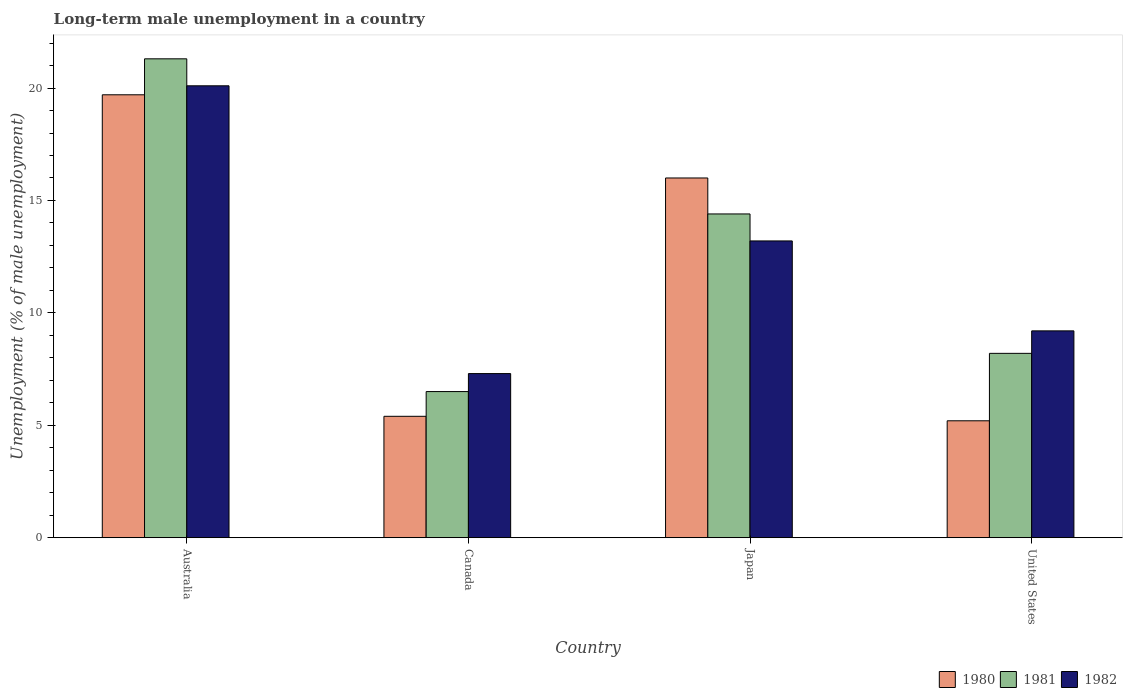How many groups of bars are there?
Keep it short and to the point. 4. What is the label of the 3rd group of bars from the left?
Offer a terse response. Japan. What is the percentage of long-term unemployed male population in 1981 in United States?
Ensure brevity in your answer.  8.2. Across all countries, what is the maximum percentage of long-term unemployed male population in 1980?
Provide a short and direct response. 19.7. In which country was the percentage of long-term unemployed male population in 1980 maximum?
Provide a succinct answer. Australia. In which country was the percentage of long-term unemployed male population in 1982 minimum?
Your response must be concise. Canada. What is the total percentage of long-term unemployed male population in 1982 in the graph?
Provide a short and direct response. 49.8. What is the difference between the percentage of long-term unemployed male population in 1982 in Canada and that in United States?
Your answer should be compact. -1.9. What is the difference between the percentage of long-term unemployed male population in 1982 in Australia and the percentage of long-term unemployed male population in 1981 in Japan?
Give a very brief answer. 5.7. What is the average percentage of long-term unemployed male population in 1981 per country?
Your response must be concise. 12.6. What is the difference between the percentage of long-term unemployed male population of/in 1982 and percentage of long-term unemployed male population of/in 1981 in Japan?
Provide a short and direct response. -1.2. What is the ratio of the percentage of long-term unemployed male population in 1980 in Canada to that in United States?
Ensure brevity in your answer.  1.04. Is the percentage of long-term unemployed male population in 1980 in Australia less than that in Canada?
Give a very brief answer. No. Is the difference between the percentage of long-term unemployed male population in 1982 in Japan and United States greater than the difference between the percentage of long-term unemployed male population in 1981 in Japan and United States?
Your answer should be compact. No. What is the difference between the highest and the second highest percentage of long-term unemployed male population in 1980?
Offer a very short reply. -3.7. What is the difference between the highest and the lowest percentage of long-term unemployed male population in 1980?
Your answer should be very brief. 14.5. What does the 2nd bar from the left in Canada represents?
Offer a terse response. 1981. Is it the case that in every country, the sum of the percentage of long-term unemployed male population in 1980 and percentage of long-term unemployed male population in 1982 is greater than the percentage of long-term unemployed male population in 1981?
Your response must be concise. Yes. How many bars are there?
Offer a terse response. 12. How many countries are there in the graph?
Keep it short and to the point. 4. Are the values on the major ticks of Y-axis written in scientific E-notation?
Provide a short and direct response. No. Does the graph contain any zero values?
Ensure brevity in your answer.  No. Where does the legend appear in the graph?
Keep it short and to the point. Bottom right. How many legend labels are there?
Offer a terse response. 3. What is the title of the graph?
Offer a very short reply. Long-term male unemployment in a country. Does "1962" appear as one of the legend labels in the graph?
Your answer should be compact. No. What is the label or title of the X-axis?
Your answer should be compact. Country. What is the label or title of the Y-axis?
Offer a terse response. Unemployment (% of male unemployment). What is the Unemployment (% of male unemployment) in 1980 in Australia?
Your answer should be very brief. 19.7. What is the Unemployment (% of male unemployment) of 1981 in Australia?
Ensure brevity in your answer.  21.3. What is the Unemployment (% of male unemployment) in 1982 in Australia?
Provide a short and direct response. 20.1. What is the Unemployment (% of male unemployment) in 1980 in Canada?
Ensure brevity in your answer.  5.4. What is the Unemployment (% of male unemployment) of 1981 in Canada?
Offer a terse response. 6.5. What is the Unemployment (% of male unemployment) of 1982 in Canada?
Provide a succinct answer. 7.3. What is the Unemployment (% of male unemployment) in 1981 in Japan?
Your response must be concise. 14.4. What is the Unemployment (% of male unemployment) in 1982 in Japan?
Make the answer very short. 13.2. What is the Unemployment (% of male unemployment) of 1980 in United States?
Your response must be concise. 5.2. What is the Unemployment (% of male unemployment) of 1981 in United States?
Give a very brief answer. 8.2. What is the Unemployment (% of male unemployment) of 1982 in United States?
Give a very brief answer. 9.2. Across all countries, what is the maximum Unemployment (% of male unemployment) of 1980?
Offer a very short reply. 19.7. Across all countries, what is the maximum Unemployment (% of male unemployment) of 1981?
Offer a terse response. 21.3. Across all countries, what is the maximum Unemployment (% of male unemployment) of 1982?
Offer a very short reply. 20.1. Across all countries, what is the minimum Unemployment (% of male unemployment) of 1980?
Give a very brief answer. 5.2. Across all countries, what is the minimum Unemployment (% of male unemployment) in 1981?
Ensure brevity in your answer.  6.5. Across all countries, what is the minimum Unemployment (% of male unemployment) in 1982?
Provide a succinct answer. 7.3. What is the total Unemployment (% of male unemployment) in 1980 in the graph?
Provide a short and direct response. 46.3. What is the total Unemployment (% of male unemployment) in 1981 in the graph?
Ensure brevity in your answer.  50.4. What is the total Unemployment (% of male unemployment) in 1982 in the graph?
Keep it short and to the point. 49.8. What is the difference between the Unemployment (% of male unemployment) in 1981 in Australia and that in Canada?
Provide a short and direct response. 14.8. What is the difference between the Unemployment (% of male unemployment) of 1982 in Australia and that in Canada?
Your answer should be compact. 12.8. What is the difference between the Unemployment (% of male unemployment) of 1982 in Australia and that in Japan?
Provide a short and direct response. 6.9. What is the difference between the Unemployment (% of male unemployment) in 1980 in Australia and that in United States?
Your response must be concise. 14.5. What is the difference between the Unemployment (% of male unemployment) in 1981 in Canada and that in Japan?
Make the answer very short. -7.9. What is the difference between the Unemployment (% of male unemployment) of 1980 in Canada and that in United States?
Provide a short and direct response. 0.2. What is the difference between the Unemployment (% of male unemployment) in 1981 in Canada and that in United States?
Make the answer very short. -1.7. What is the difference between the Unemployment (% of male unemployment) of 1982 in Canada and that in United States?
Give a very brief answer. -1.9. What is the difference between the Unemployment (% of male unemployment) in 1982 in Japan and that in United States?
Offer a terse response. 4. What is the difference between the Unemployment (% of male unemployment) in 1980 in Australia and the Unemployment (% of male unemployment) in 1981 in Canada?
Keep it short and to the point. 13.2. What is the difference between the Unemployment (% of male unemployment) in 1981 in Australia and the Unemployment (% of male unemployment) in 1982 in Canada?
Offer a very short reply. 14. What is the difference between the Unemployment (% of male unemployment) in 1980 in Canada and the Unemployment (% of male unemployment) in 1981 in Japan?
Your answer should be very brief. -9. What is the difference between the Unemployment (% of male unemployment) in 1980 in Canada and the Unemployment (% of male unemployment) in 1982 in Japan?
Your answer should be very brief. -7.8. What is the difference between the Unemployment (% of male unemployment) of 1981 in Canada and the Unemployment (% of male unemployment) of 1982 in Japan?
Keep it short and to the point. -6.7. What is the difference between the Unemployment (% of male unemployment) in 1981 in Canada and the Unemployment (% of male unemployment) in 1982 in United States?
Make the answer very short. -2.7. What is the difference between the Unemployment (% of male unemployment) of 1980 in Japan and the Unemployment (% of male unemployment) of 1982 in United States?
Provide a short and direct response. 6.8. What is the average Unemployment (% of male unemployment) in 1980 per country?
Offer a very short reply. 11.57. What is the average Unemployment (% of male unemployment) in 1981 per country?
Ensure brevity in your answer.  12.6. What is the average Unemployment (% of male unemployment) of 1982 per country?
Provide a succinct answer. 12.45. What is the difference between the Unemployment (% of male unemployment) in 1980 and Unemployment (% of male unemployment) in 1981 in Australia?
Give a very brief answer. -1.6. What is the difference between the Unemployment (% of male unemployment) in 1981 and Unemployment (% of male unemployment) in 1982 in Australia?
Provide a short and direct response. 1.2. What is the difference between the Unemployment (% of male unemployment) in 1981 and Unemployment (% of male unemployment) in 1982 in Canada?
Offer a terse response. -0.8. What is the difference between the Unemployment (% of male unemployment) of 1980 and Unemployment (% of male unemployment) of 1981 in Japan?
Provide a succinct answer. 1.6. What is the difference between the Unemployment (% of male unemployment) in 1981 and Unemployment (% of male unemployment) in 1982 in United States?
Your answer should be very brief. -1. What is the ratio of the Unemployment (% of male unemployment) of 1980 in Australia to that in Canada?
Your answer should be compact. 3.65. What is the ratio of the Unemployment (% of male unemployment) in 1981 in Australia to that in Canada?
Your answer should be very brief. 3.28. What is the ratio of the Unemployment (% of male unemployment) in 1982 in Australia to that in Canada?
Your response must be concise. 2.75. What is the ratio of the Unemployment (% of male unemployment) of 1980 in Australia to that in Japan?
Make the answer very short. 1.23. What is the ratio of the Unemployment (% of male unemployment) of 1981 in Australia to that in Japan?
Provide a short and direct response. 1.48. What is the ratio of the Unemployment (% of male unemployment) of 1982 in Australia to that in Japan?
Your response must be concise. 1.52. What is the ratio of the Unemployment (% of male unemployment) of 1980 in Australia to that in United States?
Give a very brief answer. 3.79. What is the ratio of the Unemployment (% of male unemployment) of 1981 in Australia to that in United States?
Give a very brief answer. 2.6. What is the ratio of the Unemployment (% of male unemployment) of 1982 in Australia to that in United States?
Your answer should be compact. 2.18. What is the ratio of the Unemployment (% of male unemployment) of 1980 in Canada to that in Japan?
Provide a short and direct response. 0.34. What is the ratio of the Unemployment (% of male unemployment) of 1981 in Canada to that in Japan?
Ensure brevity in your answer.  0.45. What is the ratio of the Unemployment (% of male unemployment) in 1982 in Canada to that in Japan?
Keep it short and to the point. 0.55. What is the ratio of the Unemployment (% of male unemployment) of 1980 in Canada to that in United States?
Your answer should be compact. 1.04. What is the ratio of the Unemployment (% of male unemployment) of 1981 in Canada to that in United States?
Your response must be concise. 0.79. What is the ratio of the Unemployment (% of male unemployment) in 1982 in Canada to that in United States?
Provide a short and direct response. 0.79. What is the ratio of the Unemployment (% of male unemployment) of 1980 in Japan to that in United States?
Your response must be concise. 3.08. What is the ratio of the Unemployment (% of male unemployment) of 1981 in Japan to that in United States?
Give a very brief answer. 1.76. What is the ratio of the Unemployment (% of male unemployment) of 1982 in Japan to that in United States?
Keep it short and to the point. 1.43. What is the difference between the highest and the second highest Unemployment (% of male unemployment) of 1980?
Offer a very short reply. 3.7. What is the difference between the highest and the second highest Unemployment (% of male unemployment) of 1981?
Provide a succinct answer. 6.9. 